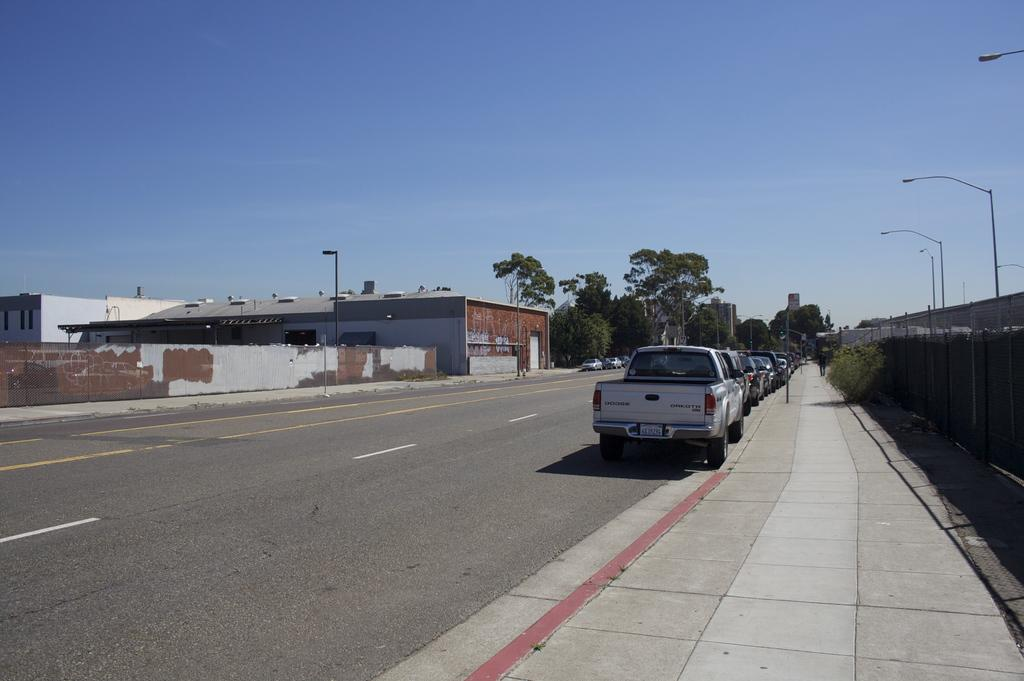What type of location is depicted in the image? The image is of a city. What can be seen on the path in the image? There are vehicles parked on the path in the image. What structures are present in the image? There are buildings in the image. Are there any natural elements visible in the image? Yes, plants and trees are present in the image. What type of infrastructure is visible in the image? Poles and a road are visible in the image. What type of illumination is present in the image? Lights are present in the image. What can be seen in the background of the image? The sky is visible in the background of the image. How many cats are solving a riddle on the roof of the building in the image? There are no cats or riddles present in the image; it depicts a cityscape with various urban elements. What type of snack is being served in the image? There is no snack, such as popcorn, present in the image. 